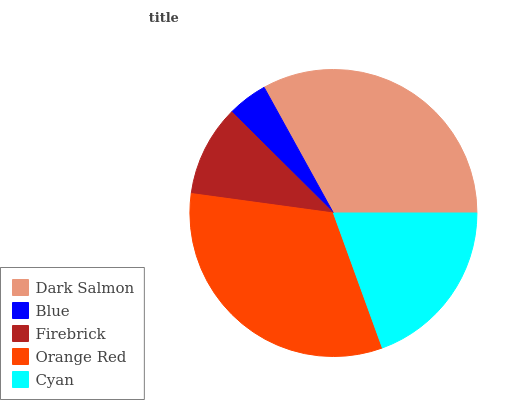Is Blue the minimum?
Answer yes or no. Yes. Is Dark Salmon the maximum?
Answer yes or no. Yes. Is Firebrick the minimum?
Answer yes or no. No. Is Firebrick the maximum?
Answer yes or no. No. Is Firebrick greater than Blue?
Answer yes or no. Yes. Is Blue less than Firebrick?
Answer yes or no. Yes. Is Blue greater than Firebrick?
Answer yes or no. No. Is Firebrick less than Blue?
Answer yes or no. No. Is Cyan the high median?
Answer yes or no. Yes. Is Cyan the low median?
Answer yes or no. Yes. Is Blue the high median?
Answer yes or no. No. Is Firebrick the low median?
Answer yes or no. No. 